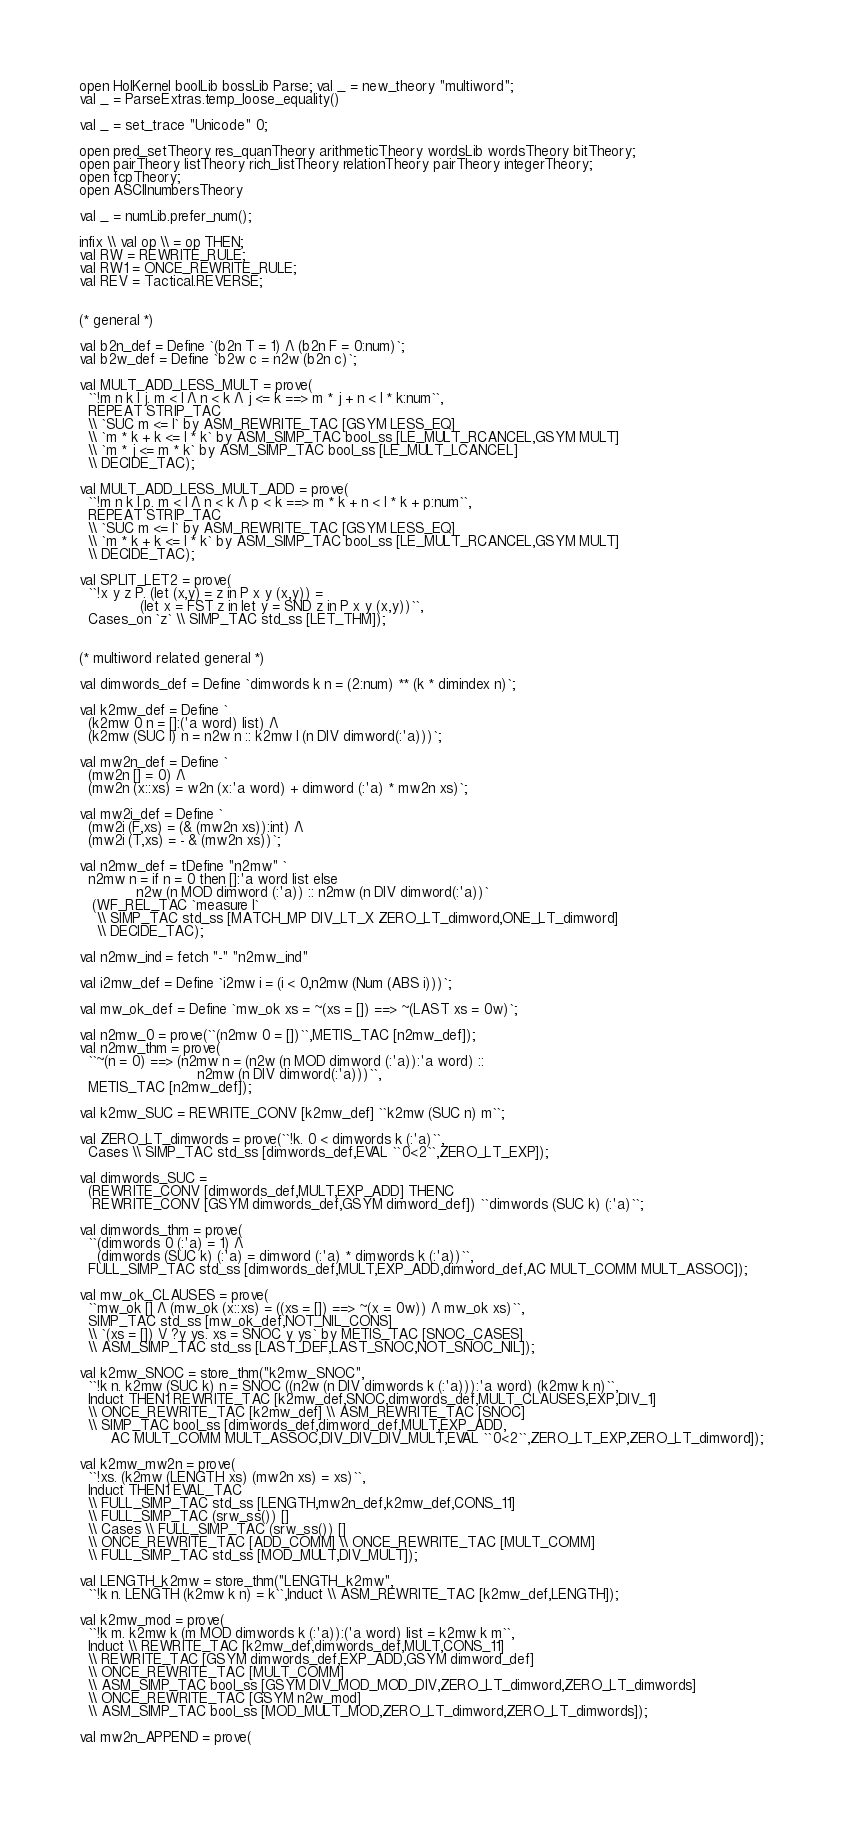<code> <loc_0><loc_0><loc_500><loc_500><_SML_>
open HolKernel boolLib bossLib Parse; val _ = new_theory "multiword";
val _ = ParseExtras.temp_loose_equality()

val _ = set_trace "Unicode" 0;

open pred_setTheory res_quanTheory arithmeticTheory wordsLib wordsTheory bitTheory;
open pairTheory listTheory rich_listTheory relationTheory pairTheory integerTheory;
open fcpTheory;
open ASCIInumbersTheory

val _ = numLib.prefer_num();

infix \\ val op \\ = op THEN;
val RW = REWRITE_RULE;
val RW1 = ONCE_REWRITE_RULE;
val REV = Tactical.REVERSE;


(* general *)

val b2n_def = Define `(b2n T = 1) /\ (b2n F = 0:num)`;
val b2w_def = Define `b2w c = n2w (b2n c)`;

val MULT_ADD_LESS_MULT = prove(
  ``!m n k l j. m < l /\ n < k /\ j <= k ==> m * j + n < l * k:num``,
  REPEAT STRIP_TAC
  \\ `SUC m <= l` by ASM_REWRITE_TAC [GSYM LESS_EQ]
  \\ `m * k + k <= l * k` by ASM_SIMP_TAC bool_ss [LE_MULT_RCANCEL,GSYM MULT]
  \\ `m * j <= m * k` by ASM_SIMP_TAC bool_ss [LE_MULT_LCANCEL]
  \\ DECIDE_TAC);

val MULT_ADD_LESS_MULT_ADD = prove(
  ``!m n k l p. m < l /\ n < k /\ p < k ==> m * k + n < l * k + p:num``,
  REPEAT STRIP_TAC
  \\ `SUC m <= l` by ASM_REWRITE_TAC [GSYM LESS_EQ]
  \\ `m * k + k <= l * k` by ASM_SIMP_TAC bool_ss [LE_MULT_RCANCEL,GSYM MULT]
  \\ DECIDE_TAC);

val SPLIT_LET2 = prove(
  ``!x y z P. (let (x,y) = z in P x y (x,y)) =
              (let x = FST z in let y = SND z in P x y (x,y))``,
  Cases_on `z` \\ SIMP_TAC std_ss [LET_THM]);


(* multiword related general *)

val dimwords_def = Define `dimwords k n = (2:num) ** (k * dimindex n)`;

val k2mw_def = Define `
  (k2mw 0 n = []:('a word) list) /\
  (k2mw (SUC l) n = n2w n :: k2mw l (n DIV dimword(:'a)))`;

val mw2n_def = Define `
  (mw2n [] = 0) /\
  (mw2n (x::xs) = w2n (x:'a word) + dimword (:'a) * mw2n xs)`;

val mw2i_def = Define `
  (mw2i (F,xs) = (& (mw2n xs)):int) /\
  (mw2i (T,xs) = - & (mw2n xs))`;

val n2mw_def = tDefine "n2mw" `
  n2mw n = if n = 0 then []:'a word list else
             n2w (n MOD dimword (:'a)) :: n2mw (n DIV dimword(:'a))`
   (WF_REL_TAC `measure I`
    \\ SIMP_TAC std_ss [MATCH_MP DIV_LT_X ZERO_LT_dimword,ONE_LT_dimword]
    \\ DECIDE_TAC);

val n2mw_ind = fetch "-" "n2mw_ind"

val i2mw_def = Define `i2mw i = (i < 0,n2mw (Num (ABS i)))`;

val mw_ok_def = Define `mw_ok xs = ~(xs = []) ==> ~(LAST xs = 0w)`;

val n2mw_0 = prove(``(n2mw 0 = [])``,METIS_TAC [n2mw_def]);
val n2mw_thm = prove(
  ``~(n = 0) ==> (n2mw n = (n2w (n MOD dimword (:'a)):'a word) ::
                           n2mw (n DIV dimword(:'a)))``,
  METIS_TAC [n2mw_def]);

val k2mw_SUC = REWRITE_CONV [k2mw_def] ``k2mw (SUC n) m``;

val ZERO_LT_dimwords = prove(``!k. 0 < dimwords k (:'a)``,
  Cases \\ SIMP_TAC std_ss [dimwords_def,EVAL ``0<2``,ZERO_LT_EXP]);

val dimwords_SUC =
  (REWRITE_CONV [dimwords_def,MULT,EXP_ADD] THENC
   REWRITE_CONV [GSYM dimwords_def,GSYM dimword_def]) ``dimwords (SUC k) (:'a)``;

val dimwords_thm = prove(
  ``(dimwords 0 (:'a) = 1) /\
    (dimwords (SUC k) (:'a) = dimword (:'a) * dimwords k (:'a))``,
  FULL_SIMP_TAC std_ss [dimwords_def,MULT,EXP_ADD,dimword_def,AC MULT_COMM MULT_ASSOC]);

val mw_ok_CLAUSES = prove(
  ``mw_ok [] /\ (mw_ok (x::xs) = ((xs = []) ==> ~(x = 0w)) /\ mw_ok xs)``,
  SIMP_TAC std_ss [mw_ok_def,NOT_NIL_CONS]
  \\ `(xs = []) \/ ?y ys. xs = SNOC y ys` by METIS_TAC [SNOC_CASES]
  \\ ASM_SIMP_TAC std_ss [LAST_DEF,LAST_SNOC,NOT_SNOC_NIL]);

val k2mw_SNOC = store_thm("k2mw_SNOC",
  ``!k n. k2mw (SUC k) n = SNOC ((n2w (n DIV dimwords k (:'a))):'a word) (k2mw k n)``,
  Induct THEN1 REWRITE_TAC [k2mw_def,SNOC,dimwords_def,MULT_CLAUSES,EXP,DIV_1]
  \\ ONCE_REWRITE_TAC [k2mw_def] \\ ASM_REWRITE_TAC [SNOC]
  \\ SIMP_TAC bool_ss [dimwords_def,dimword_def,MULT,EXP_ADD,
       AC MULT_COMM MULT_ASSOC,DIV_DIV_DIV_MULT,EVAL ``0<2``,ZERO_LT_EXP,ZERO_LT_dimword]);

val k2mw_mw2n = prove(
  ``!xs. (k2mw (LENGTH xs) (mw2n xs) = xs)``,
  Induct THEN1 EVAL_TAC
  \\ FULL_SIMP_TAC std_ss [LENGTH,mw2n_def,k2mw_def,CONS_11]
  \\ FULL_SIMP_TAC (srw_ss()) []
  \\ Cases \\ FULL_SIMP_TAC (srw_ss()) []
  \\ ONCE_REWRITE_TAC [ADD_COMM] \\ ONCE_REWRITE_TAC [MULT_COMM]
  \\ FULL_SIMP_TAC std_ss [MOD_MULT,DIV_MULT]);

val LENGTH_k2mw = store_thm("LENGTH_k2mw",
  ``!k n. LENGTH (k2mw k n) = k``,Induct \\ ASM_REWRITE_TAC [k2mw_def,LENGTH]);

val k2mw_mod = prove(
  ``!k m. k2mw k (m MOD dimwords k (:'a)):('a word) list = k2mw k m``,
  Induct \\ REWRITE_TAC [k2mw_def,dimwords_def,MULT,CONS_11]
  \\ REWRITE_TAC [GSYM dimwords_def,EXP_ADD,GSYM dimword_def]
  \\ ONCE_REWRITE_TAC [MULT_COMM]
  \\ ASM_SIMP_TAC bool_ss [GSYM DIV_MOD_MOD_DIV,ZERO_LT_dimword,ZERO_LT_dimwords]
  \\ ONCE_REWRITE_TAC [GSYM n2w_mod]
  \\ ASM_SIMP_TAC bool_ss [MOD_MULT_MOD,ZERO_LT_dimword,ZERO_LT_dimwords]);

val mw2n_APPEND = prove(</code> 